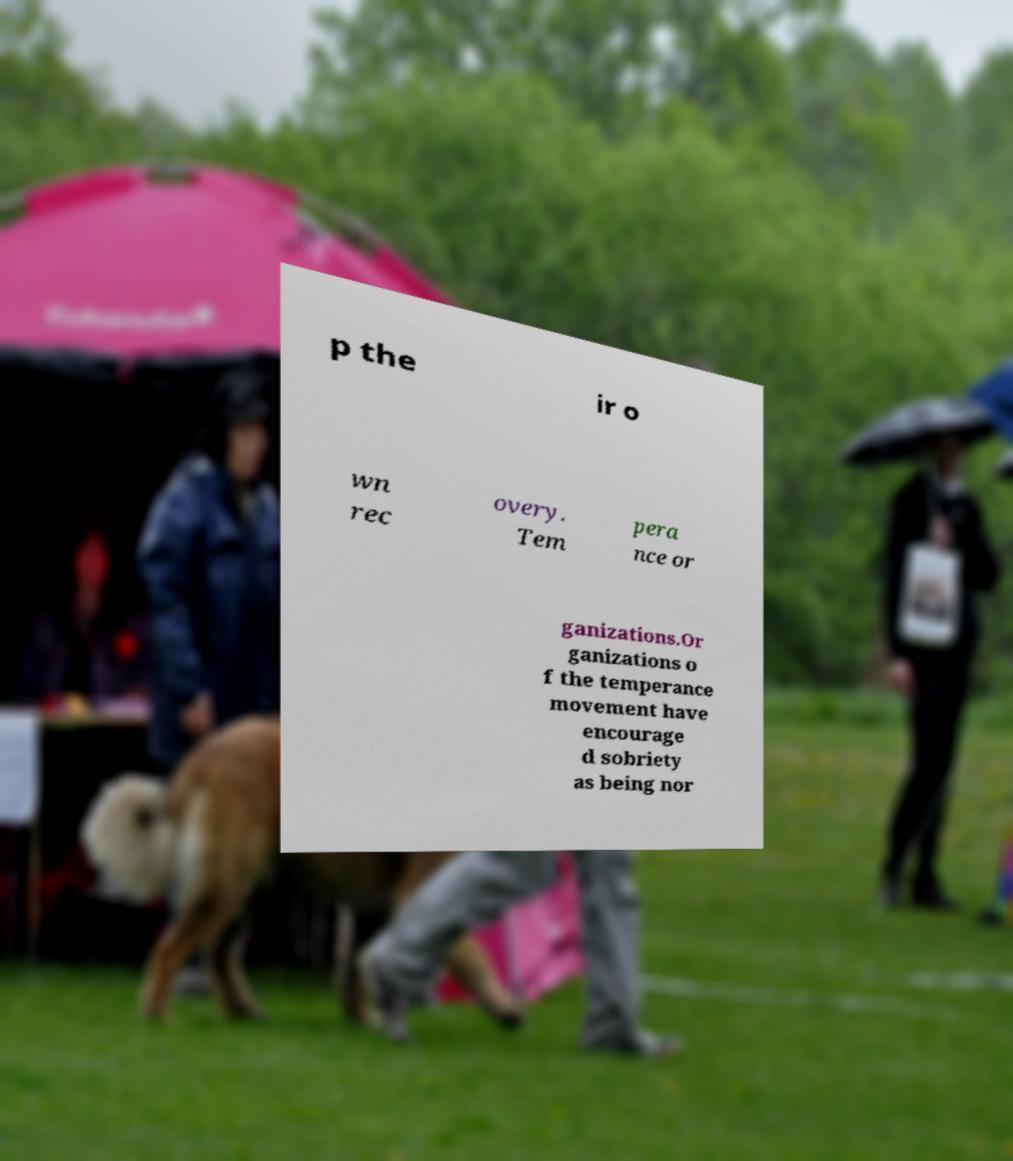There's text embedded in this image that I need extracted. Can you transcribe it verbatim? p the ir o wn rec overy. Tem pera nce or ganizations.Or ganizations o f the temperance movement have encourage d sobriety as being nor 